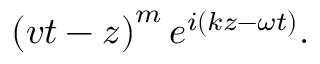Convert formula to latex. <formula><loc_0><loc_0><loc_500><loc_500>\left ( v t - z \right ) ^ { m } e ^ { i \left ( k z - \omega t \right ) } .</formula> 